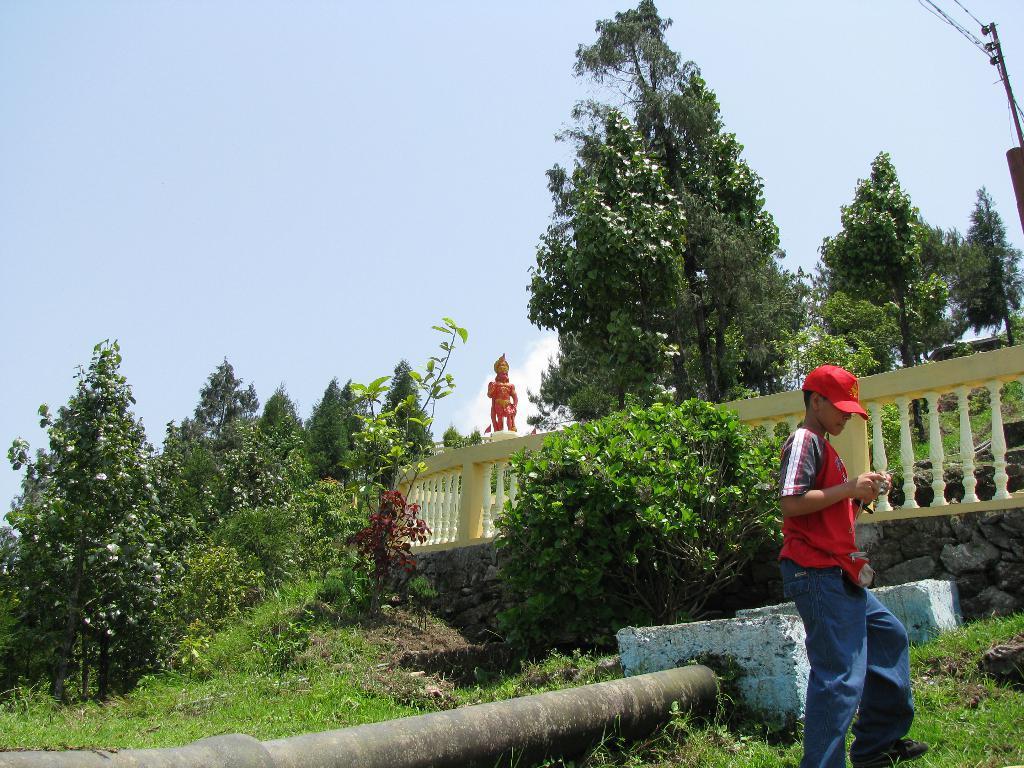Could you give a brief overview of what you see in this image? In this picture we can see a boy wore a helmet and standing on the ground, trees, pipe, fence, statue and in the background we can see the sky. 